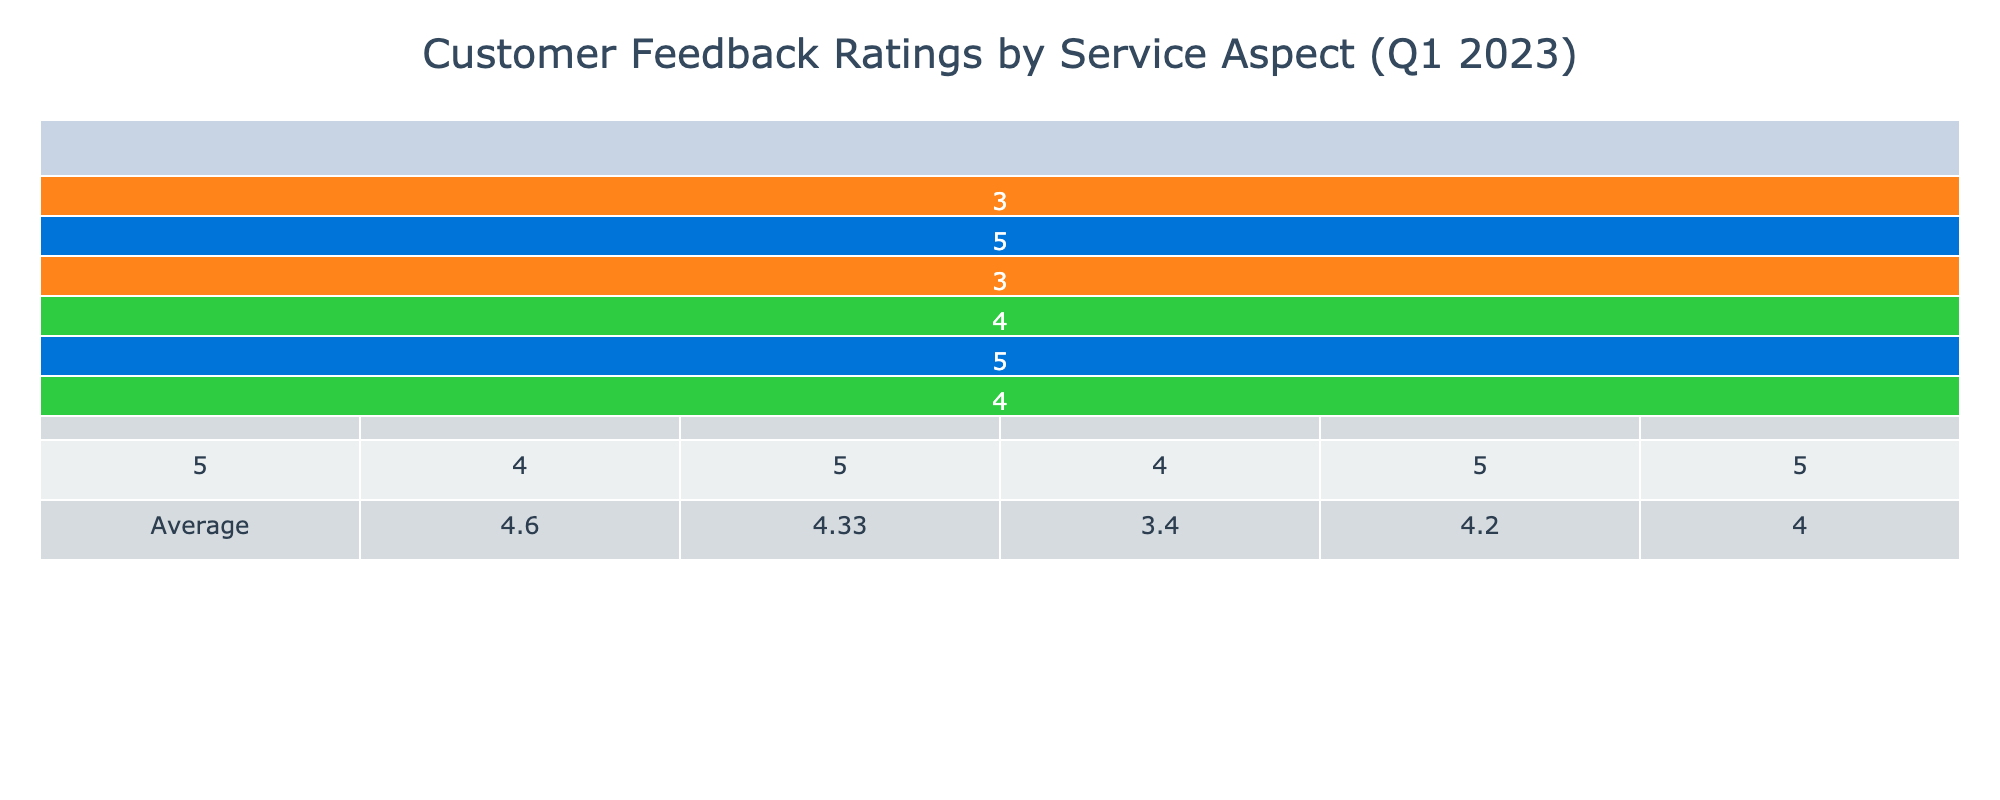What was the feedback rating for Cleanliness from Customer 003? From the table, we can locate Customer 003's row and check the Cleanliness column. The rating for Cleanliness is 5.
Answer: 5 What is the average feedback rating for Speed of Service across all customers? We will take the Speed of Service ratings from each customer: 3 (Customer 001), 4 (Customer 002), 2 (Customer 003), 4 (Customer 004), and 4 (Customer 005). The sum is 3 + 4 + 2 + 4 + 4 = 17, and there are 5 customers. The average is 17/5 = 3.4.
Answer: 3.4 Is the feedback rating for Value for Money higher for Customer 005 than Customer 001? Looking at the table, Customer 005 has a Value for Money rating of 5, while Customer 001 has a rating of 3. Since 5 is greater than 3, the statement is true.
Answer: Yes What is the highest feedback rating for Staff Attitude among all customers? By checking the Staff Attitude ratings for each customer, we find 4 (Customer 001), 5 (Customer 002), 3 (Customer 003), 4 (Customer 004), and 5 (Customer 005). The highest rating is 5.
Answer: 5 Which customer gave the lowest rating for Speed of Service? Reviewing the Speed of Service ratings, we see: 3 (Customer 001), 4 (Customer 002), 2 (Customer 003), 4 (Customer 004), and 4 (Customer 005). Customer 003 with a rating of 2 has the lowest rating.
Answer: Customer 003 What is the difference between the highest and lowest ratings for Cleanliness across all customers? The Cleanliness ratings are 5 (Customer 001), 4 (Customer 002), 5 (Customer 003), 5 (Customer 004), and 4 (Customer 005). The highest rating is 5 and the lowest is 4. Thus, the difference is 5 - 4 = 1.
Answer: 1 How many customers rated Product Quality and what was the average rating? Product Quality ratings are available for Customer 002 (5), Customer 004 (3), and Customer 005 (5). There are 3 customers with ratings: 5 + 3 + 5 = 13, and the average is 13/3 ≈ 4.33.
Answer: 4.33 Did any customer rate Staff Attitude under 3? Checking the Staff Attitude ratings, we find values: 4 (Customer 001), 5 (Customer 002), 3 (Customer 003), 4 (Customer 004), and 5 (Customer 005). There are no ratings under 3.
Answer: No What service aspect did Customer 005 rate the highest? Identifying Customer 005's ratings: Staff Attitude (5), Cleanliness (4), Speed of Service (4), Product Quality (5), and Value for Money (5). The highest rating is for Staff Attitude, Product Quality, and Value for Money, all at 5.
Answer: Staff Attitude, Product Quality, and Value for Money Which customer had the highest overall average rating across all service aspects? Calculating the average ratings for each customer: Customer 001: (4 + 5 + 3 + 3) / 4 = 3.75; Customer 002: (5 + 4 + 4 + 5 + 5) / 5 = 4.6; Customer 003: (3 + 5 + 2 + 3) / 4 = 3.25; Customer 004: (4 + 5 + 4 + 3 + 4) / 5 = 4.0; Customer 005: (5 + 4 + 4 + 5 + 5) / 5 = 4.6. Customers 002 and 005 have the highest average ratings at 4.6.
Answer: Customer 002 and Customer 005 